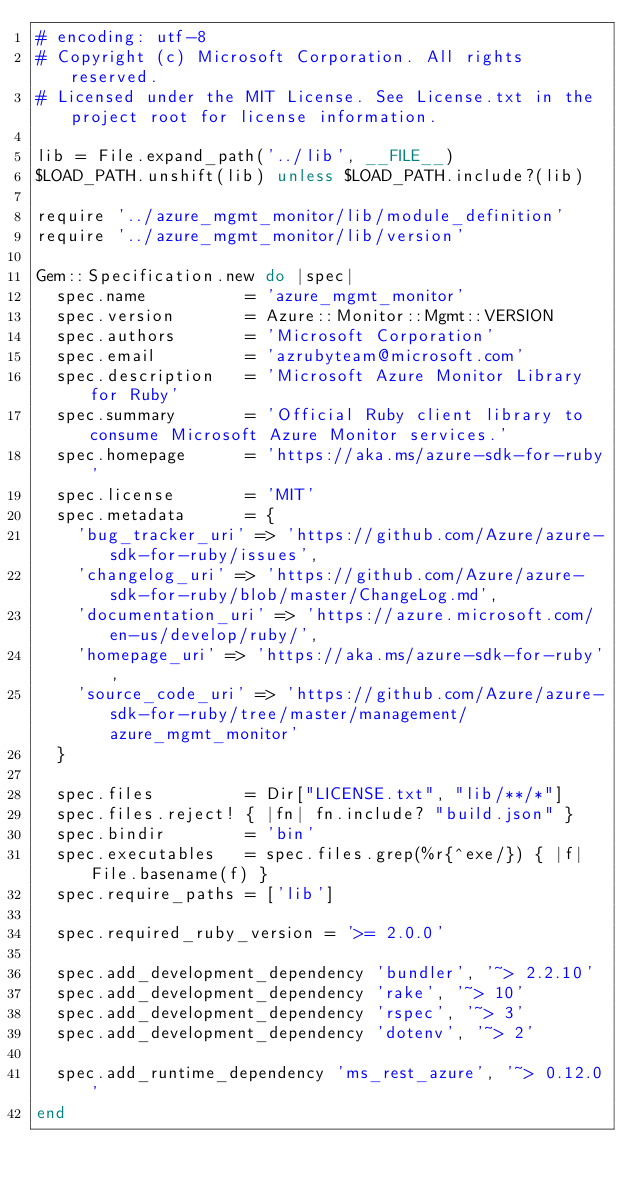<code> <loc_0><loc_0><loc_500><loc_500><_Ruby_># encoding: utf-8
# Copyright (c) Microsoft Corporation. All rights reserved.
# Licensed under the MIT License. See License.txt in the project root for license information.

lib = File.expand_path('../lib', __FILE__)
$LOAD_PATH.unshift(lib) unless $LOAD_PATH.include?(lib)

require '../azure_mgmt_monitor/lib/module_definition'
require '../azure_mgmt_monitor/lib/version'

Gem::Specification.new do |spec|
  spec.name          = 'azure_mgmt_monitor'
  spec.version       = Azure::Monitor::Mgmt::VERSION
  spec.authors       = 'Microsoft Corporation'
  spec.email         = 'azrubyteam@microsoft.com'
  spec.description   = 'Microsoft Azure Monitor Library for Ruby'
  spec.summary       = 'Official Ruby client library to consume Microsoft Azure Monitor services.'
  spec.homepage      = 'https://aka.ms/azure-sdk-for-ruby'
  spec.license       = 'MIT'
  spec.metadata      = {
    'bug_tracker_uri' => 'https://github.com/Azure/azure-sdk-for-ruby/issues',
    'changelog_uri' => 'https://github.com/Azure/azure-sdk-for-ruby/blob/master/ChangeLog.md',
    'documentation_uri' => 'https://azure.microsoft.com/en-us/develop/ruby/',
    'homepage_uri' => 'https://aka.ms/azure-sdk-for-ruby',
    'source_code_uri' => 'https://github.com/Azure/azure-sdk-for-ruby/tree/master/management/azure_mgmt_monitor'
  }

  spec.files         = Dir["LICENSE.txt", "lib/**/*"]
  spec.files.reject! { |fn| fn.include? "build.json" }
  spec.bindir        = 'bin'
  spec.executables   = spec.files.grep(%r{^exe/}) { |f| File.basename(f) }
  spec.require_paths = ['lib']

  spec.required_ruby_version = '>= 2.0.0'

  spec.add_development_dependency 'bundler', '~> 2.2.10'
  spec.add_development_dependency 'rake', '~> 10'
  spec.add_development_dependency 'rspec', '~> 3'
  spec.add_development_dependency 'dotenv', '~> 2'

  spec.add_runtime_dependency 'ms_rest_azure', '~> 0.12.0'
end
</code> 